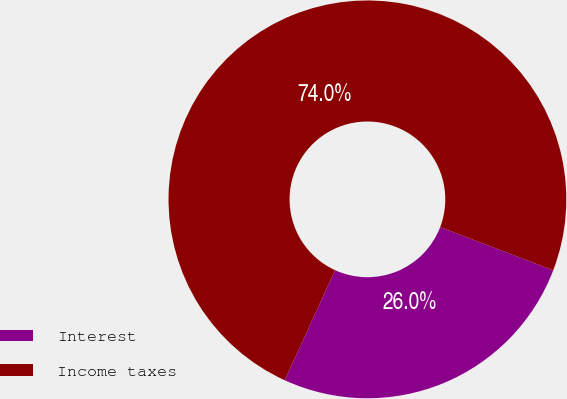Convert chart to OTSL. <chart><loc_0><loc_0><loc_500><loc_500><pie_chart><fcel>Interest<fcel>Income taxes<nl><fcel>26.02%<fcel>73.98%<nl></chart> 